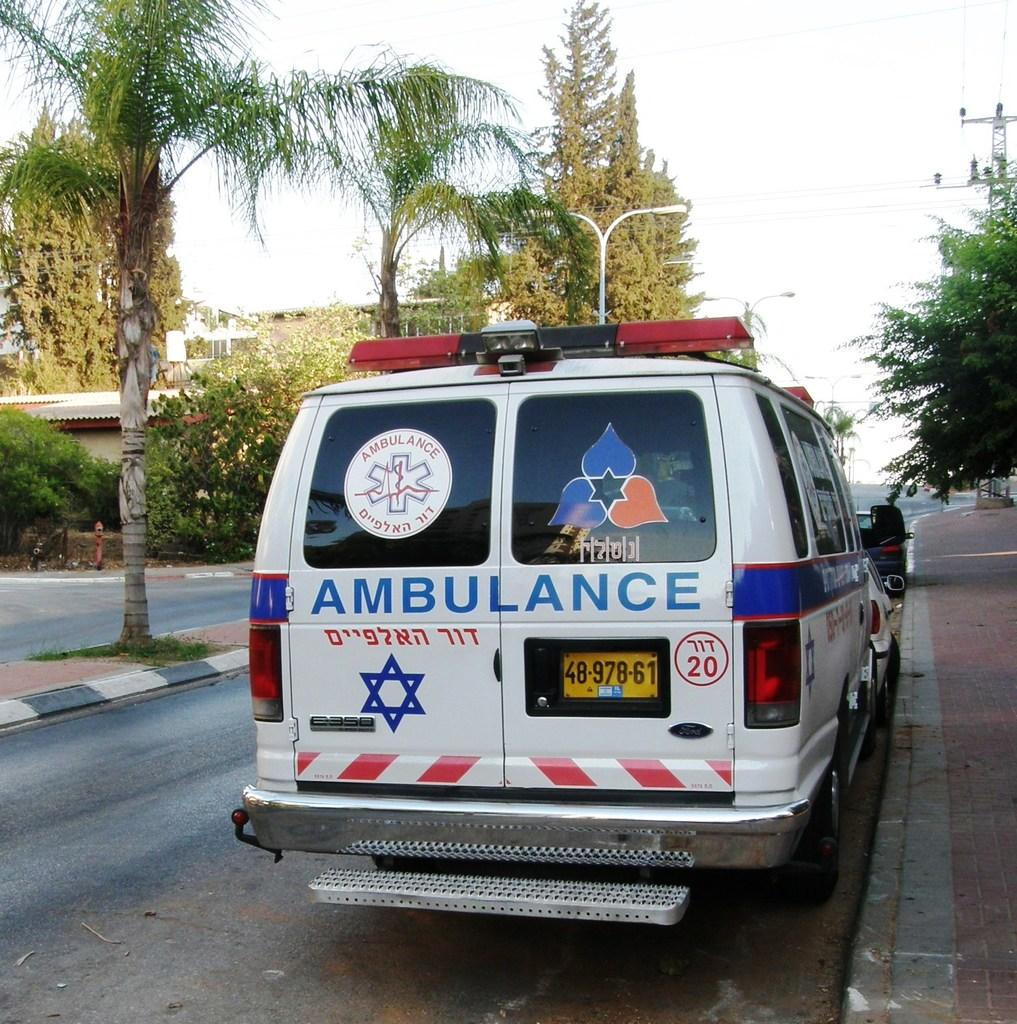<image>
Provide a brief description of the given image. An ambulance with a Jewish star on the back is number 20. 